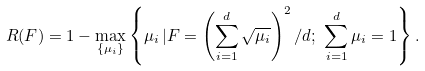<formula> <loc_0><loc_0><loc_500><loc_500>R ( F ) = 1 - \max _ { \{ \mu _ { i } \} } \left \{ \mu _ { i } \, | F = \left ( \sum _ { i = 1 } ^ { d } \sqrt { \mu _ { i } } \right ) ^ { 2 } / d ; \ \sum _ { i = 1 } ^ { d } \mu _ { i } = 1 \right \} .</formula> 